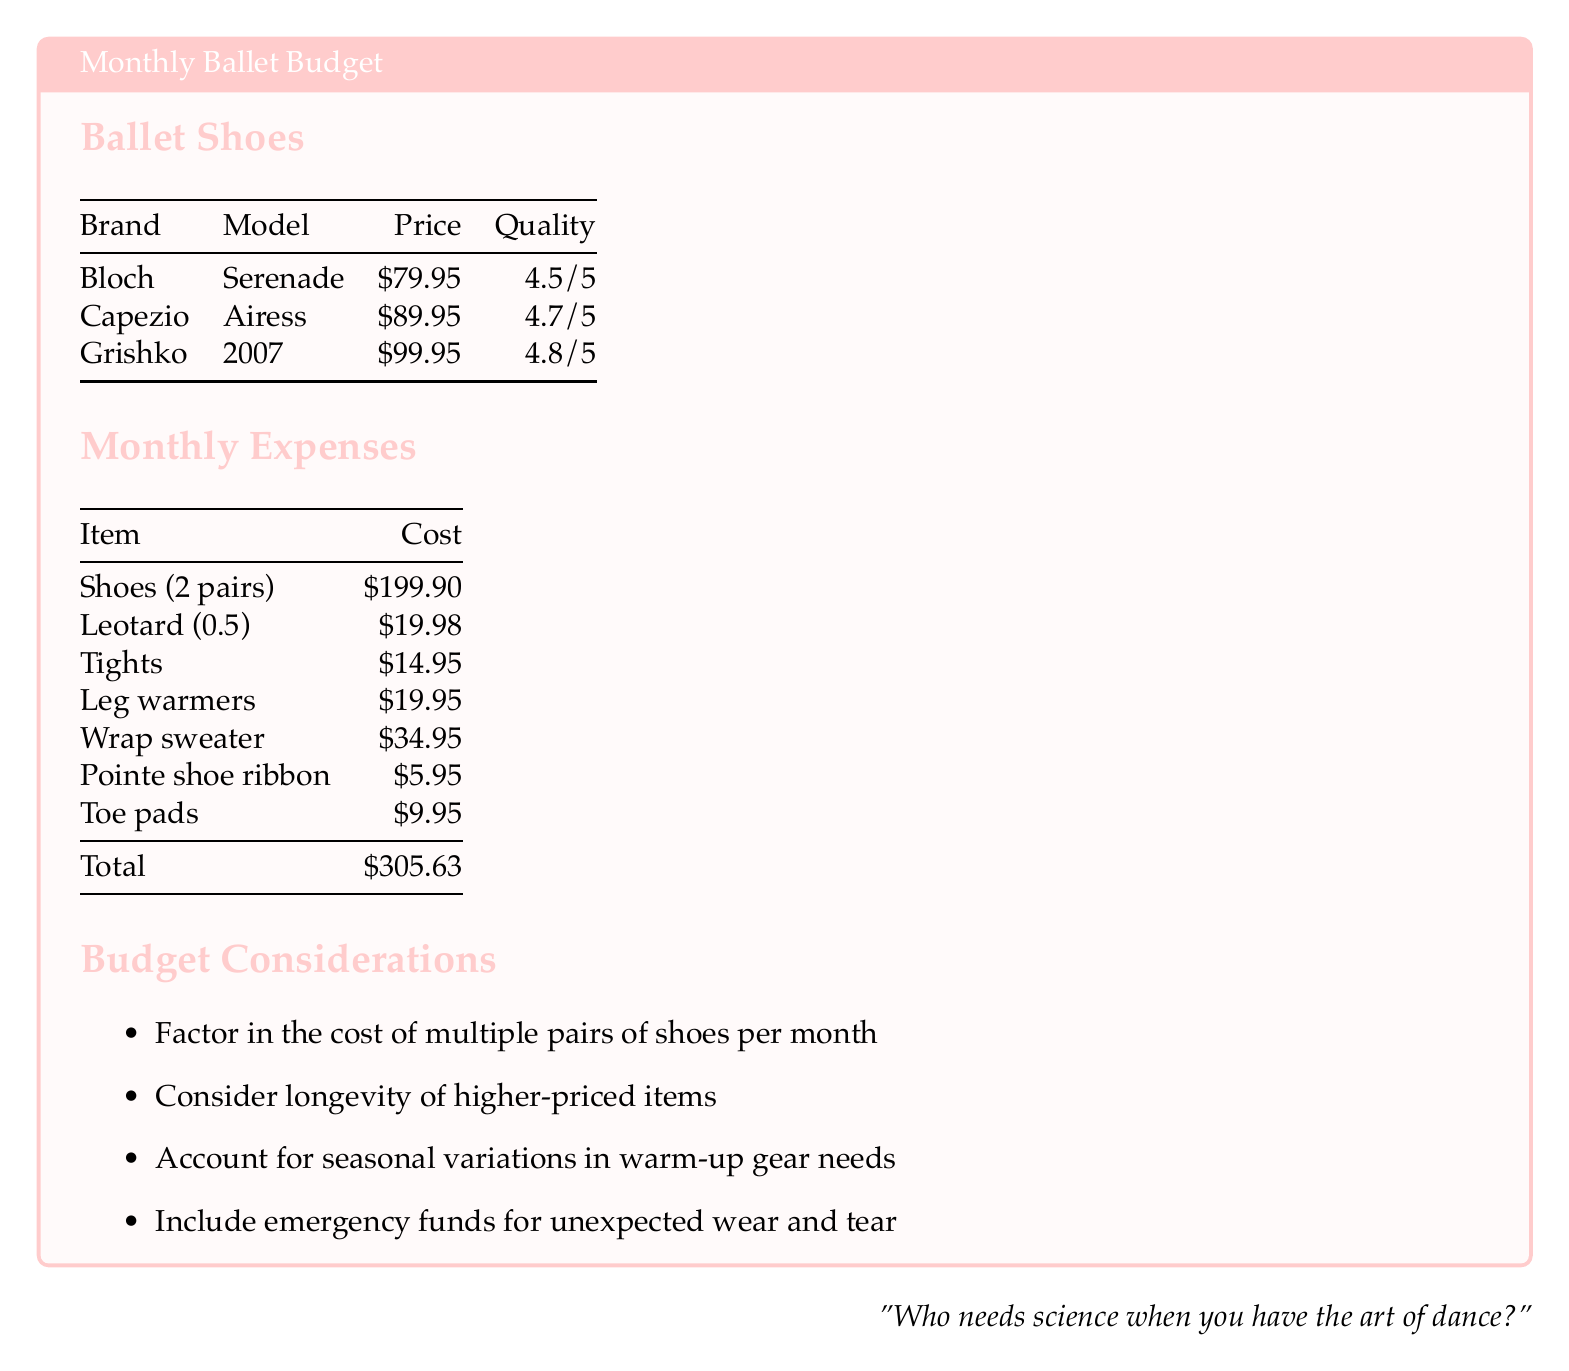What is the price of the Capezio Airess shoes? The price for Capezio Airess shoes is specifically listed in the ballet shoes section of the document, which states it's $89.95.
Answer: $89.95 What is the quality rating for Grishko 2007? The quality rating for Grishko 2007 is provided in the ballet shoes section, which shows it is rated at 4.8/5.
Answer: 4.8/5 How much does a leotard cost monthly in this budget? The cost for a leotard is indicated in the monthly expenses section, which shows it's $19.98 for 0.5 of a leotard.
Answer: $19.98 What is the total estimated monthly ballet budget? The total estimated monthly ballet budget is the sum of all listed expenses in the monthly expenses section, which totals $305.63.
Answer: $305.63 Which brand has the highest quality rating? The highest quality rating is found by comparing the ratings in the ballet shoes section; Grishko has the highest with a rating of 4.8/5.
Answer: Grishko What item costs $14.95? The monthly expenses section lists tights, priced at $14.95.
Answer: Tights What should be factored in regarding shoes? The document mentions that multiple pairs of shoes per month need to be factored into the budget considerations.
Answer: Multiple pairs How much do toe pads cost? The monthly expenses section includes the cost of toe pads, stated to be $9.95.
Answer: $9.95 What is included in emergency funds? The budget considerations note that emergency funds are needed for unexpected wear and tear on items.
Answer: Unexpected wear and tear 